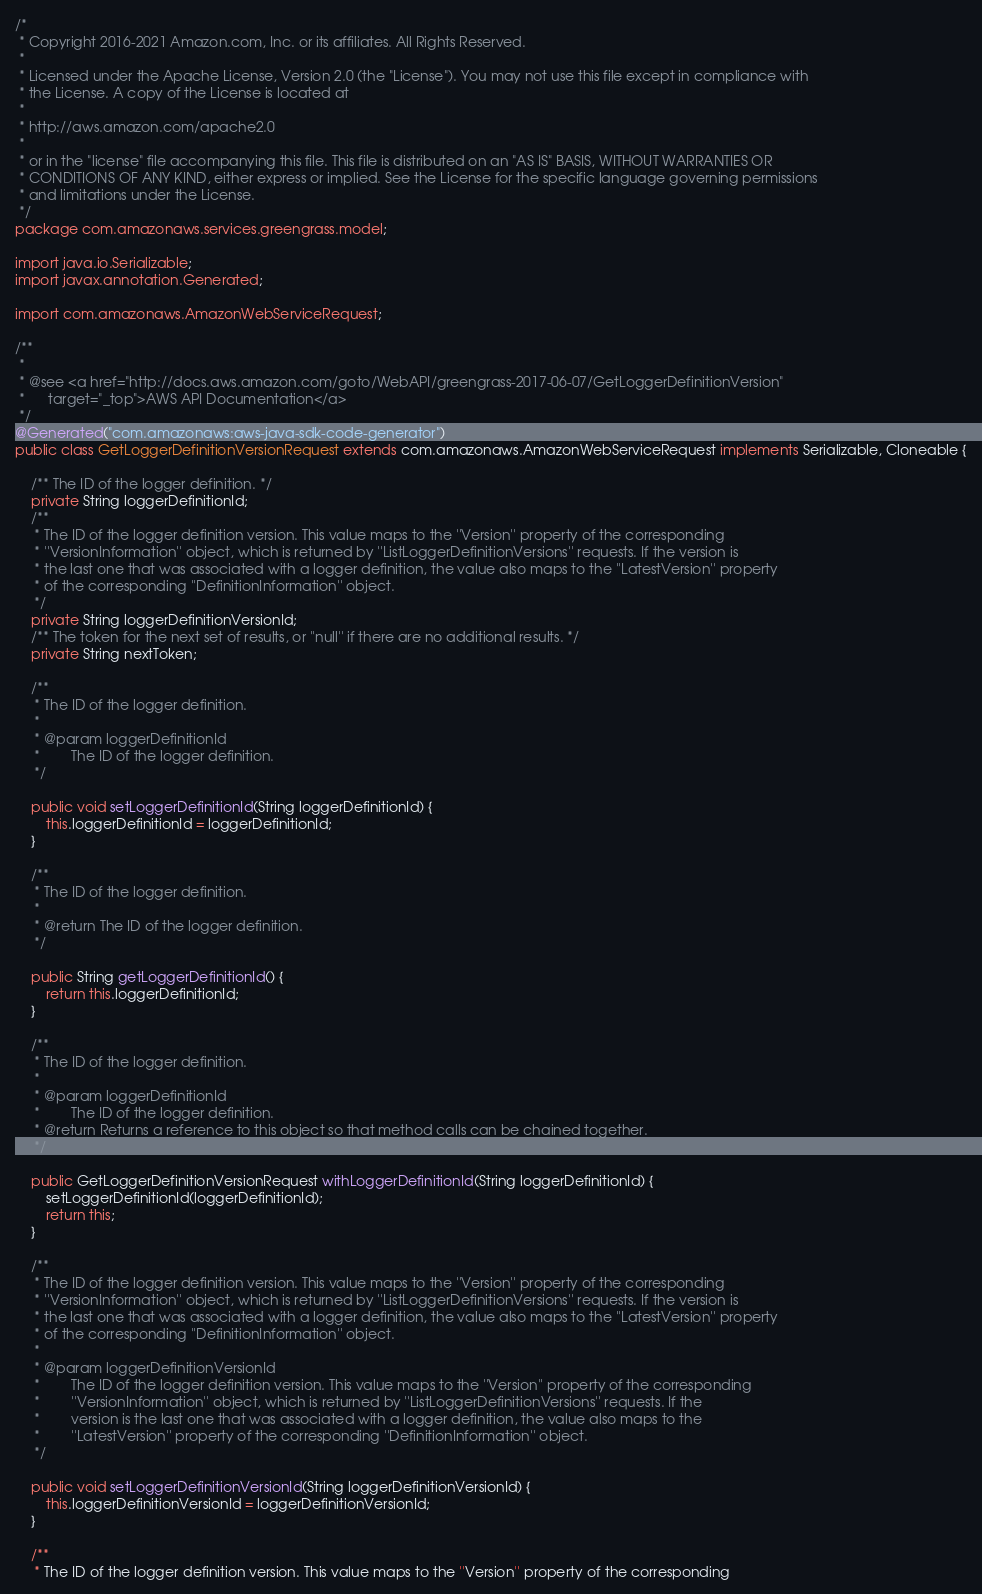Convert code to text. <code><loc_0><loc_0><loc_500><loc_500><_Java_>/*
 * Copyright 2016-2021 Amazon.com, Inc. or its affiliates. All Rights Reserved.
 * 
 * Licensed under the Apache License, Version 2.0 (the "License"). You may not use this file except in compliance with
 * the License. A copy of the License is located at
 * 
 * http://aws.amazon.com/apache2.0
 * 
 * or in the "license" file accompanying this file. This file is distributed on an "AS IS" BASIS, WITHOUT WARRANTIES OR
 * CONDITIONS OF ANY KIND, either express or implied. See the License for the specific language governing permissions
 * and limitations under the License.
 */
package com.amazonaws.services.greengrass.model;

import java.io.Serializable;
import javax.annotation.Generated;

import com.amazonaws.AmazonWebServiceRequest;

/**
 * 
 * @see <a href="http://docs.aws.amazon.com/goto/WebAPI/greengrass-2017-06-07/GetLoggerDefinitionVersion"
 *      target="_top">AWS API Documentation</a>
 */
@Generated("com.amazonaws:aws-java-sdk-code-generator")
public class GetLoggerDefinitionVersionRequest extends com.amazonaws.AmazonWebServiceRequest implements Serializable, Cloneable {

    /** The ID of the logger definition. */
    private String loggerDefinitionId;
    /**
     * The ID of the logger definition version. This value maps to the ''Version'' property of the corresponding
     * ''VersionInformation'' object, which is returned by ''ListLoggerDefinitionVersions'' requests. If the version is
     * the last one that was associated with a logger definition, the value also maps to the ''LatestVersion'' property
     * of the corresponding ''DefinitionInformation'' object.
     */
    private String loggerDefinitionVersionId;
    /** The token for the next set of results, or ''null'' if there are no additional results. */
    private String nextToken;

    /**
     * The ID of the logger definition.
     * 
     * @param loggerDefinitionId
     *        The ID of the logger definition.
     */

    public void setLoggerDefinitionId(String loggerDefinitionId) {
        this.loggerDefinitionId = loggerDefinitionId;
    }

    /**
     * The ID of the logger definition.
     * 
     * @return The ID of the logger definition.
     */

    public String getLoggerDefinitionId() {
        return this.loggerDefinitionId;
    }

    /**
     * The ID of the logger definition.
     * 
     * @param loggerDefinitionId
     *        The ID of the logger definition.
     * @return Returns a reference to this object so that method calls can be chained together.
     */

    public GetLoggerDefinitionVersionRequest withLoggerDefinitionId(String loggerDefinitionId) {
        setLoggerDefinitionId(loggerDefinitionId);
        return this;
    }

    /**
     * The ID of the logger definition version. This value maps to the ''Version'' property of the corresponding
     * ''VersionInformation'' object, which is returned by ''ListLoggerDefinitionVersions'' requests. If the version is
     * the last one that was associated with a logger definition, the value also maps to the ''LatestVersion'' property
     * of the corresponding ''DefinitionInformation'' object.
     * 
     * @param loggerDefinitionVersionId
     *        The ID of the logger definition version. This value maps to the ''Version'' property of the corresponding
     *        ''VersionInformation'' object, which is returned by ''ListLoggerDefinitionVersions'' requests. If the
     *        version is the last one that was associated with a logger definition, the value also maps to the
     *        ''LatestVersion'' property of the corresponding ''DefinitionInformation'' object.
     */

    public void setLoggerDefinitionVersionId(String loggerDefinitionVersionId) {
        this.loggerDefinitionVersionId = loggerDefinitionVersionId;
    }

    /**
     * The ID of the logger definition version. This value maps to the ''Version'' property of the corresponding</code> 